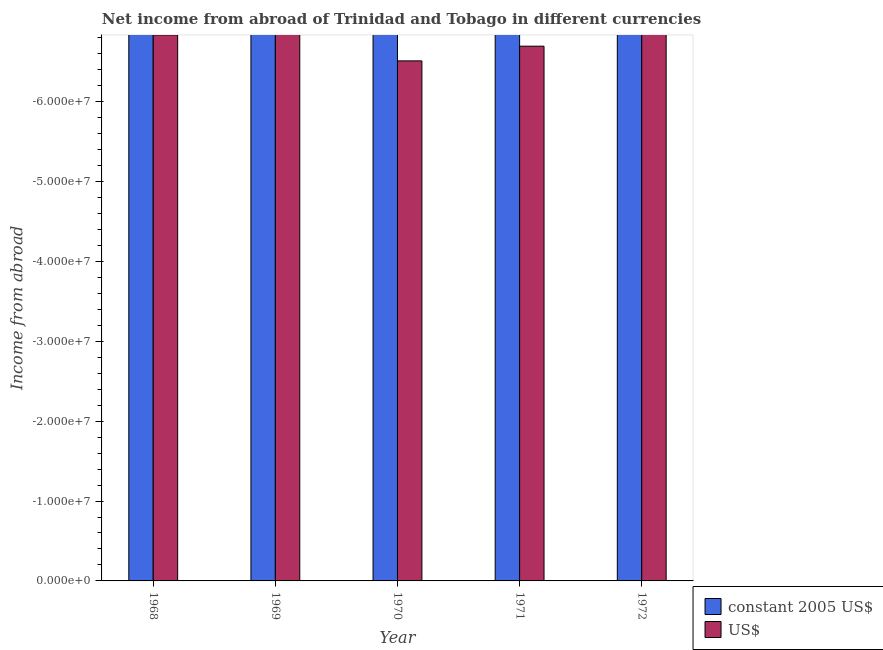Are the number of bars per tick equal to the number of legend labels?
Offer a terse response. No. How many bars are there on the 1st tick from the left?
Your answer should be very brief. 0. What is the label of the 5th group of bars from the left?
Ensure brevity in your answer.  1972. What is the income from abroad in constant 2005 us$ in 1970?
Your answer should be compact. 0. What is the average income from abroad in us$ per year?
Ensure brevity in your answer.  0. In how many years, is the income from abroad in us$ greater than -52000000 units?
Keep it short and to the point. 0. Are the values on the major ticks of Y-axis written in scientific E-notation?
Give a very brief answer. Yes. Does the graph contain grids?
Make the answer very short. No. Where does the legend appear in the graph?
Keep it short and to the point. Bottom right. How many legend labels are there?
Offer a terse response. 2. How are the legend labels stacked?
Ensure brevity in your answer.  Vertical. What is the title of the graph?
Your answer should be very brief. Net income from abroad of Trinidad and Tobago in different currencies. What is the label or title of the X-axis?
Provide a succinct answer. Year. What is the label or title of the Y-axis?
Provide a succinct answer. Income from abroad. What is the Income from abroad of constant 2005 US$ in 1968?
Provide a succinct answer. 0. What is the Income from abroad in US$ in 1968?
Your answer should be compact. 0. What is the Income from abroad of constant 2005 US$ in 1969?
Keep it short and to the point. 0. What is the Income from abroad in US$ in 1970?
Offer a very short reply. 0. What is the Income from abroad of constant 2005 US$ in 1971?
Keep it short and to the point. 0. What is the total Income from abroad of constant 2005 US$ in the graph?
Make the answer very short. 0. What is the total Income from abroad in US$ in the graph?
Your response must be concise. 0. 